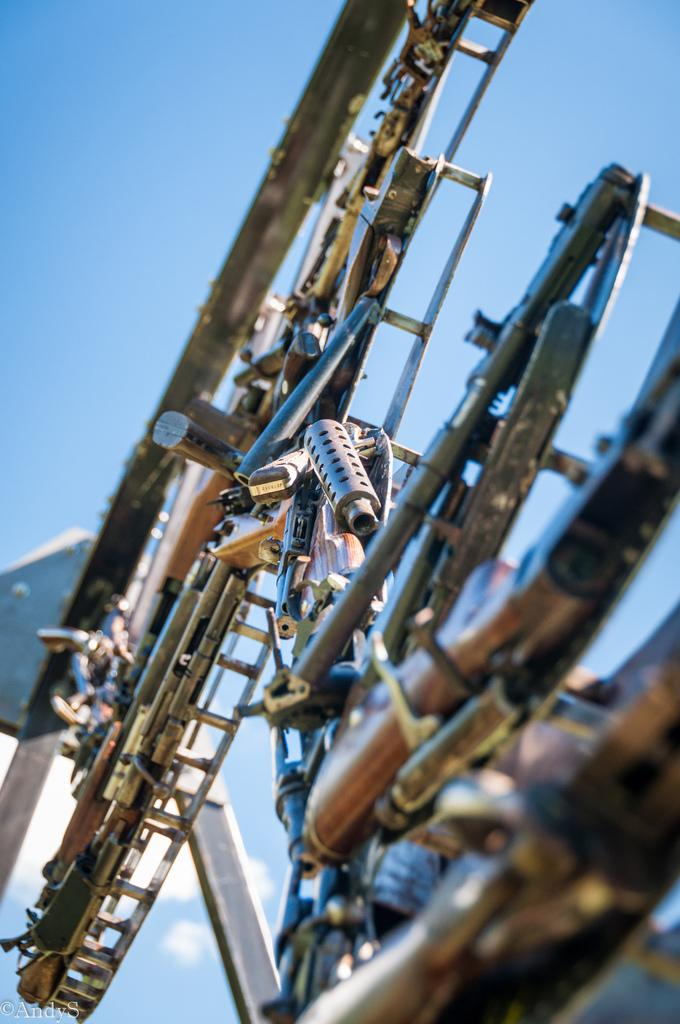What type of objects can be seen in the image? There are metal objects in the image. What can be seen in the background of the image? The sky is visible in the background of the image. Is there any additional information or markings in the image? Yes, there is a watermark in the bottom left corner of the image. Are there any dinosaurs visible in the image? No, there are no dinosaurs present in the image. 